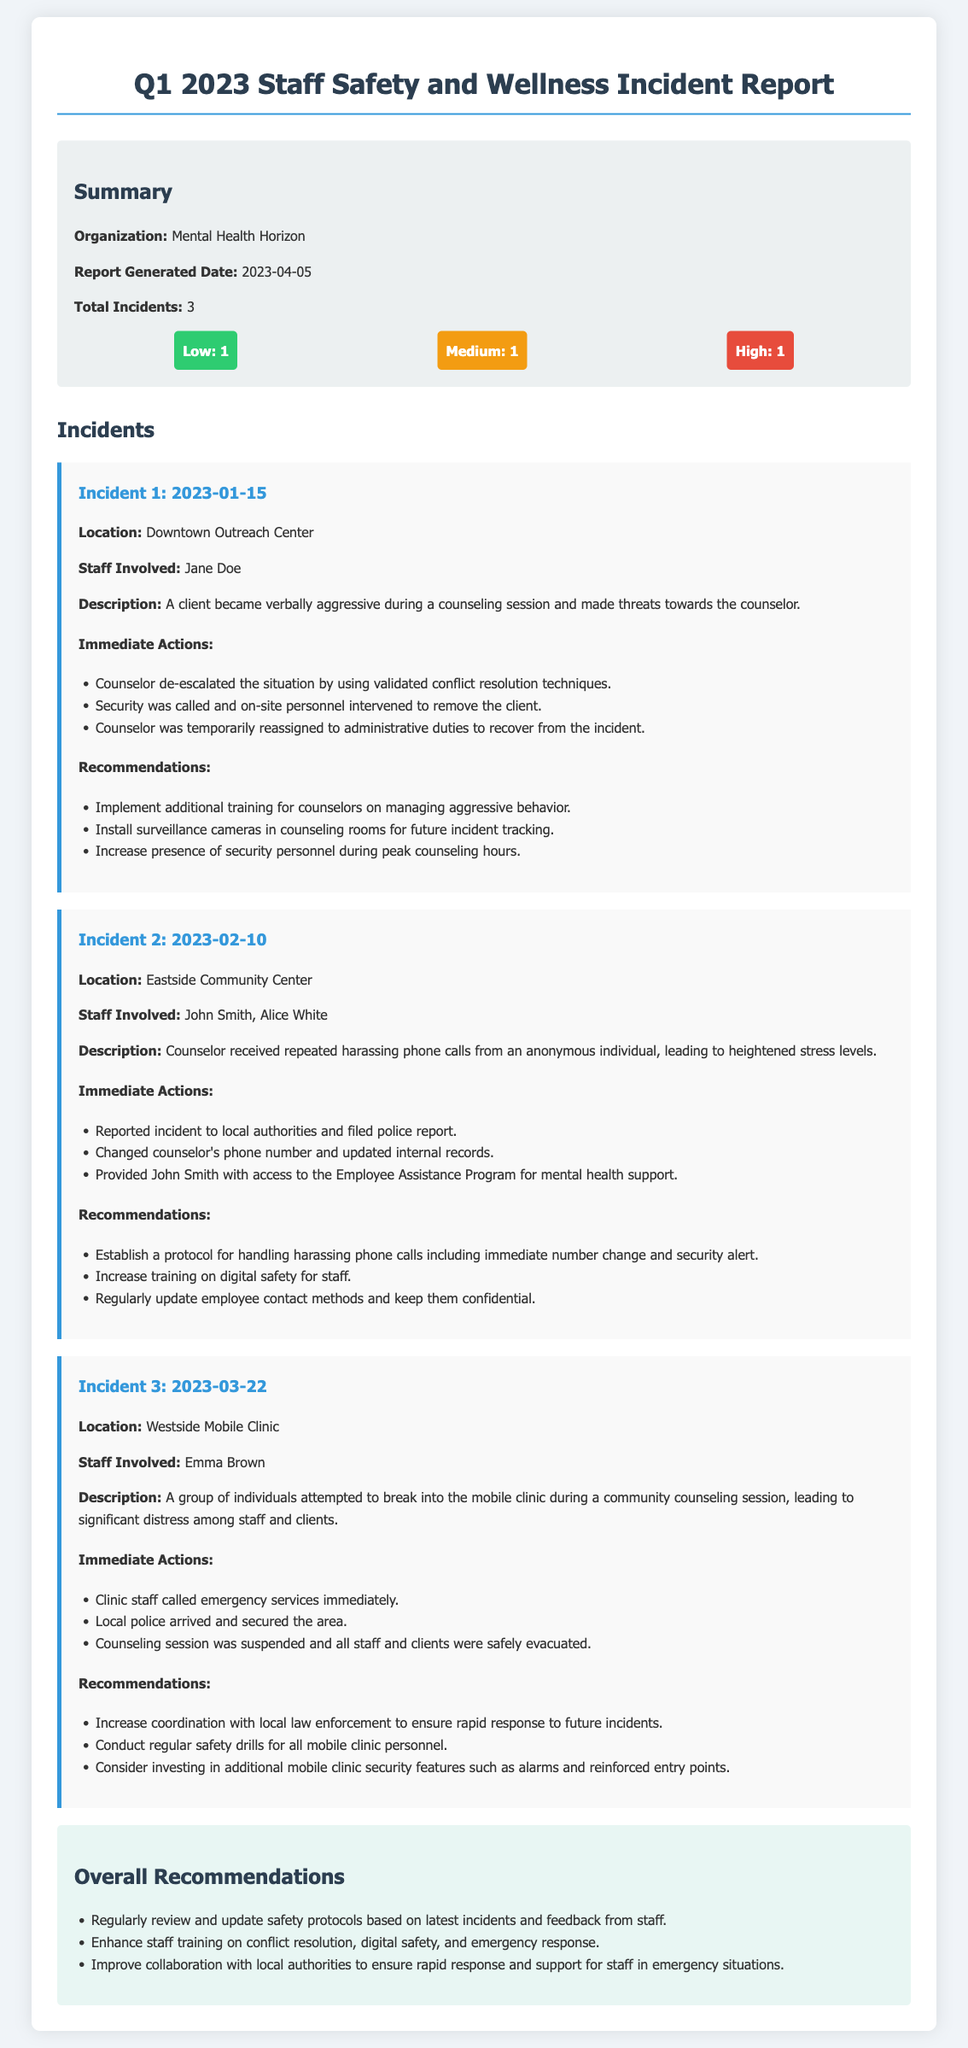What is the report generated date? The report generated date is highlighted in the summary section of the document as 2023-04-05.
Answer: 2023-04-05 How many incidents were reported? The total incidents are mentioned in the summary section, indicating there were 3 incidents reported.
Answer: 3 What was the location of Incident 2? The location for Incident 2 is specified in the details of that incident as the Eastside Community Center.
Answer: Eastside Community Center Who was involved in Incident 1? The staff involved in Incident 1 is clearly stated as Jane Doe in the incident details.
Answer: Jane Doe What immediate action was taken in Incident 3? The immediate actions taken in Incident 3 included calling emergency services, which is specifically mentioned in that incident's details.
Answer: Called emergency services What is one recommendation for future safety measures after Incident 1? A recommendation provided for future safety measures after Incident 1 is to implement additional training for counselors on managing aggressive behavior.
Answer: Additional training for counselors What severity level was assigned to Incident 2? The severity level assigned to Incident 2 is detailed in the summary section, categorized as medium.
Answer: Medium Which staff member accessed mental health support after a harassment incident? The document states that John Smith was provided access to the Employee Assistance Program for mental health support.
Answer: John Smith What overall recommendation is suggested in the report? The report includes an overall recommendation to enhance staff training on conflict resolution, commonly found in the recommendations section.
Answer: Enhance staff training on conflict resolution 